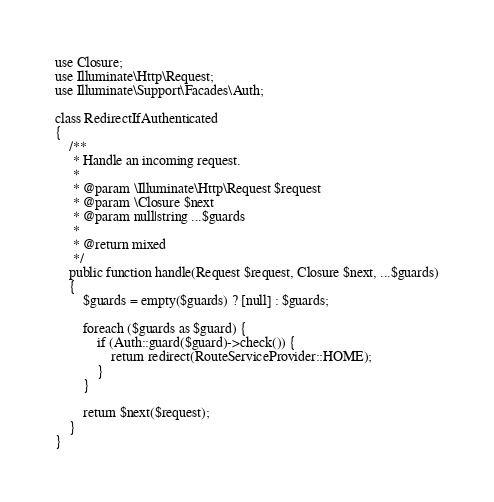<code> <loc_0><loc_0><loc_500><loc_500><_PHP_>use Closure;
use Illuminate\Http\Request;
use Illuminate\Support\Facades\Auth;

class RedirectIfAuthenticated
{
    /**
     * Handle an incoming request.
     *
     * @param \Illuminate\Http\Request $request
     * @param \Closure $next
     * @param null|string ...$guards
     *
     * @return mixed
     */
    public function handle(Request $request, Closure $next, ...$guards)
    {
        $guards = empty($guards) ? [null] : $guards;

        foreach ($guards as $guard) {
            if (Auth::guard($guard)->check()) {
                return redirect(RouteServiceProvider::HOME);
            }
        }

        return $next($request);
    }
}
</code> 